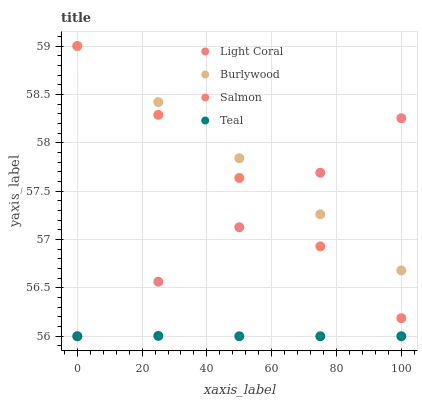Does Teal have the minimum area under the curve?
Answer yes or no. Yes. Does Burlywood have the maximum area under the curve?
Answer yes or no. Yes. Does Salmon have the minimum area under the curve?
Answer yes or no. No. Does Salmon have the maximum area under the curve?
Answer yes or no. No. Is Light Coral the smoothest?
Answer yes or no. Yes. Is Salmon the roughest?
Answer yes or no. Yes. Is Salmon the smoothest?
Answer yes or no. No. Is Burlywood the roughest?
Answer yes or no. No. Does Light Coral have the lowest value?
Answer yes or no. Yes. Does Salmon have the lowest value?
Answer yes or no. No. Does Salmon have the highest value?
Answer yes or no. Yes. Does Teal have the highest value?
Answer yes or no. No. Is Teal less than Burlywood?
Answer yes or no. Yes. Is Salmon greater than Teal?
Answer yes or no. Yes. Does Salmon intersect Light Coral?
Answer yes or no. Yes. Is Salmon less than Light Coral?
Answer yes or no. No. Is Salmon greater than Light Coral?
Answer yes or no. No. Does Teal intersect Burlywood?
Answer yes or no. No. 